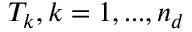Convert formula to latex. <formula><loc_0><loc_0><loc_500><loc_500>T _ { k } , k = 1 , \dots , n _ { d }</formula> 